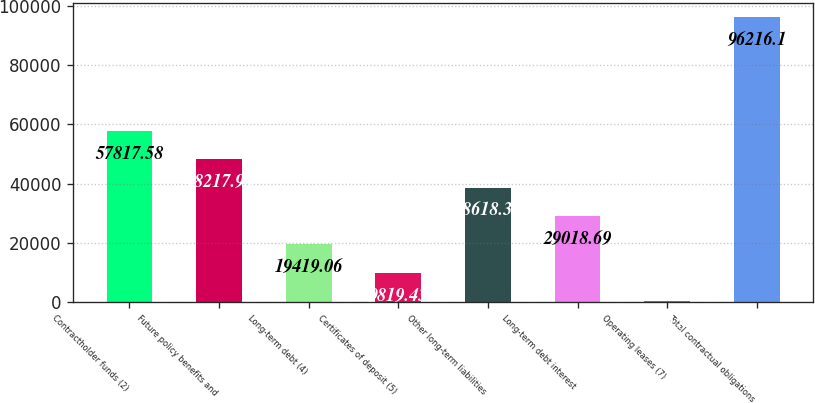Convert chart to OTSL. <chart><loc_0><loc_0><loc_500><loc_500><bar_chart><fcel>Contractholder funds (2)<fcel>Future policy benefits and<fcel>Long-term debt (4)<fcel>Certificates of deposit (5)<fcel>Other long-term liabilities<fcel>Long-term debt interest<fcel>Operating leases (7)<fcel>Total contractual obligations<nl><fcel>57817.6<fcel>48217.9<fcel>19419.1<fcel>9819.43<fcel>38618.3<fcel>29018.7<fcel>219.8<fcel>96216.1<nl></chart> 